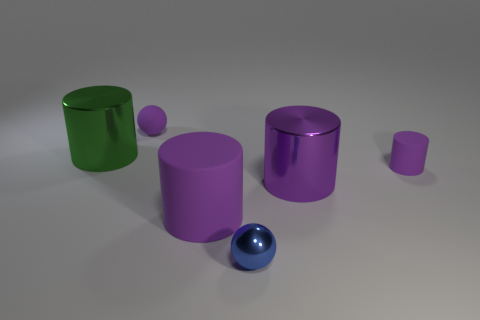Subtract all purple cylinders. How many were subtracted if there are1purple cylinders left? 2 Subtract all big purple shiny cylinders. How many cylinders are left? 3 Add 2 small purple balls. How many objects exist? 8 Subtract all cyan balls. How many purple cylinders are left? 3 Subtract all blue spheres. How many spheres are left? 1 Subtract all cylinders. How many objects are left? 2 Add 5 tiny blue balls. How many tiny blue balls are left? 6 Add 1 purple matte cylinders. How many purple matte cylinders exist? 3 Subtract 0 gray cubes. How many objects are left? 6 Subtract 1 spheres. How many spheres are left? 1 